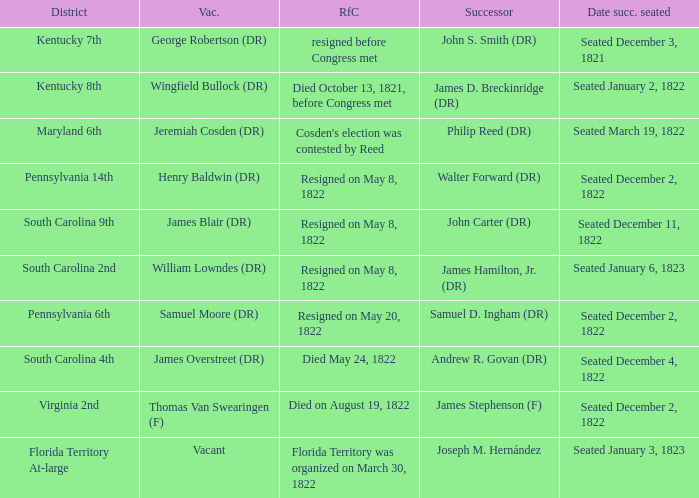Who is the successor when florida territory at-large is the district? Joseph M. Hernández. Write the full table. {'header': ['District', 'Vac.', 'RfC', 'Successor', 'Date succ. seated'], 'rows': [['Kentucky 7th', 'George Robertson (DR)', 'resigned before Congress met', 'John S. Smith (DR)', 'Seated December 3, 1821'], ['Kentucky 8th', 'Wingfield Bullock (DR)', 'Died October 13, 1821, before Congress met', 'James D. Breckinridge (DR)', 'Seated January 2, 1822'], ['Maryland 6th', 'Jeremiah Cosden (DR)', "Cosden's election was contested by Reed", 'Philip Reed (DR)', 'Seated March 19, 1822'], ['Pennsylvania 14th', 'Henry Baldwin (DR)', 'Resigned on May 8, 1822', 'Walter Forward (DR)', 'Seated December 2, 1822'], ['South Carolina 9th', 'James Blair (DR)', 'Resigned on May 8, 1822', 'John Carter (DR)', 'Seated December 11, 1822'], ['South Carolina 2nd', 'William Lowndes (DR)', 'Resigned on May 8, 1822', 'James Hamilton, Jr. (DR)', 'Seated January 6, 1823'], ['Pennsylvania 6th', 'Samuel Moore (DR)', 'Resigned on May 20, 1822', 'Samuel D. Ingham (DR)', 'Seated December 2, 1822'], ['South Carolina 4th', 'James Overstreet (DR)', 'Died May 24, 1822', 'Andrew R. Govan (DR)', 'Seated December 4, 1822'], ['Virginia 2nd', 'Thomas Van Swearingen (F)', 'Died on August 19, 1822', 'James Stephenson (F)', 'Seated December 2, 1822'], ['Florida Territory At-large', 'Vacant', 'Florida Territory was organized on March 30, 1822', 'Joseph M. Hernández', 'Seated January 3, 1823']]} 